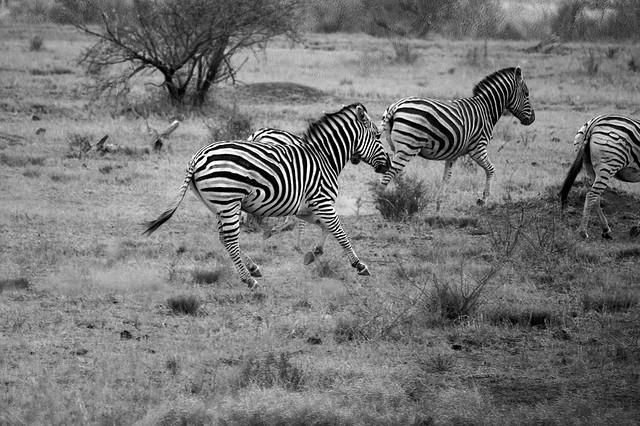How many zebras are running in the savannah area? Please explain your reasoning. two. There are four zebras in the photo but only two of them are running. 